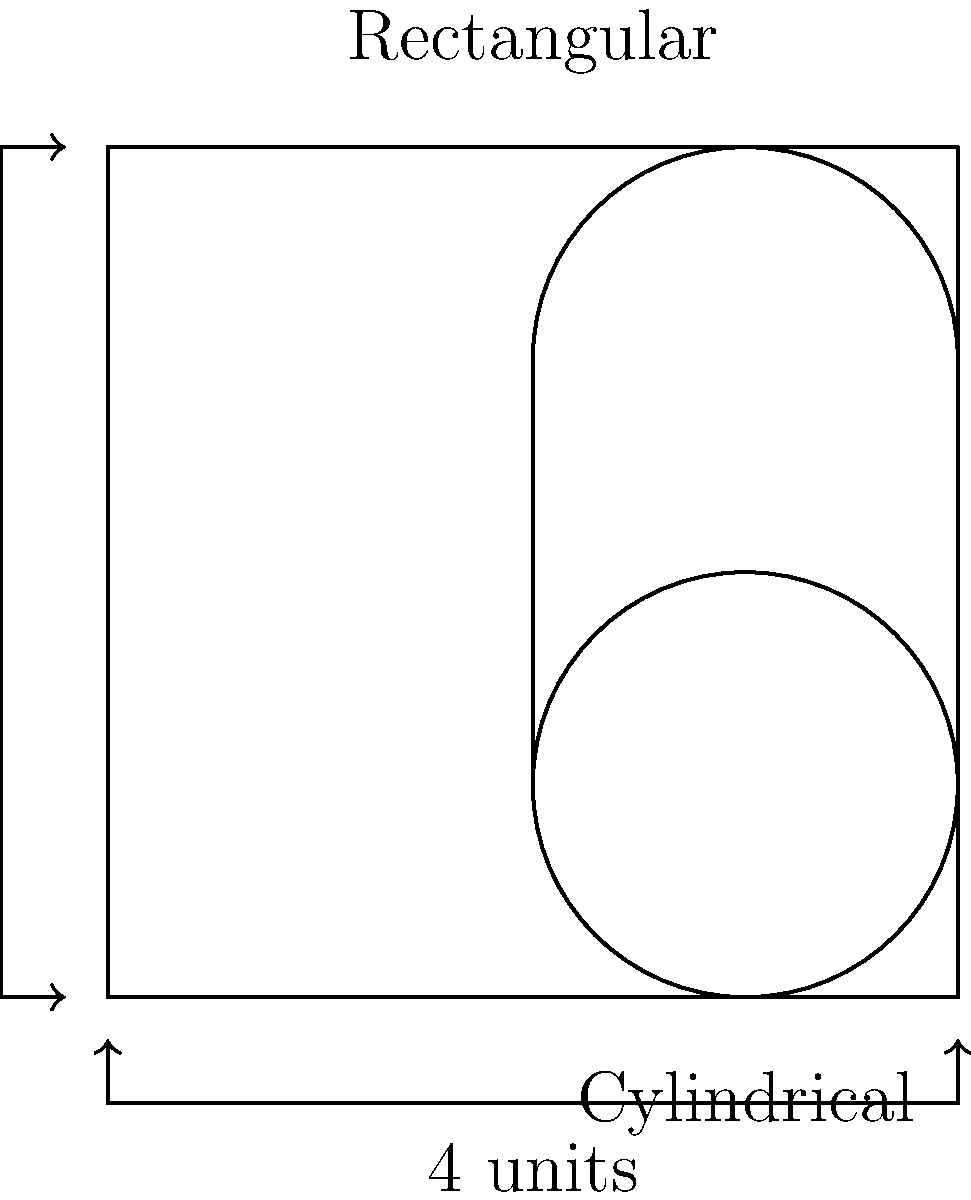As a fishmonger, you need to optimize your storage space for fresh fish. You have two container options: a cylindrical container with a diameter of 2 units and a height of 2 units, and a rectangular container with dimensions 4 x 4 x 2 units (length x width x height). Which container provides more storage volume for your fish, and by how much? Let's calculate the volume of each container:

1. Cylindrical container:
   Volume = $\pi r^2 h$
   where $r$ is the radius (1 unit) and $h$ is the height (2 units)
   $V_{cylinder} = \pi \cdot 1^2 \cdot 2 = 2\pi$ cubic units

2. Rectangular container:
   Volume = length x width x height
   $V_{rectangle} = 4 \cdot 4 \cdot 2 = 32$ cubic units

3. Compare the volumes:
   Difference = $V_{rectangle} - V_{cylinder}$
   $= 32 - 2\pi$
   $\approx 32 - 6.28 = 25.72$ cubic units

4. Calculate the percentage difference:
   Percentage difference = $\frac{\text{Difference}}{\text{Smaller volume}} \times 100\%$
   $= \frac{32 - 2\pi}{2\pi} \times 100\% \approx 409\%$

The rectangular container provides approximately 25.72 cubic units more storage space, which is about 409% more volume than the cylindrical container.
Answer: Rectangular container; 25.72 cubic units (409%) more 